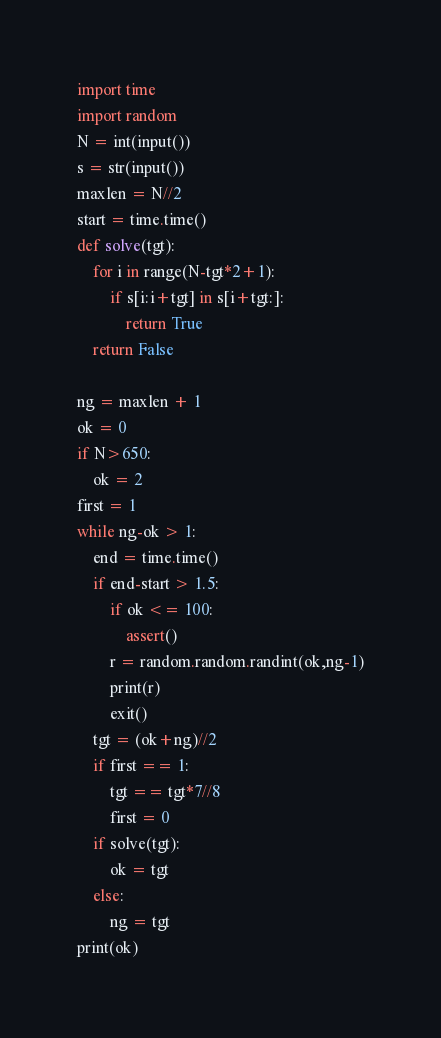Convert code to text. <code><loc_0><loc_0><loc_500><loc_500><_Python_>import time
import random
N = int(input())
s = str(input())
maxlen = N//2
start = time.time()
def solve(tgt):
    for i in range(N-tgt*2+1):
        if s[i:i+tgt] in s[i+tgt:]:
            return True
    return False

ng = maxlen + 1
ok = 0
if N>650:
    ok = 2
first = 1
while ng-ok > 1:
    end = time.time()
    if end-start > 1.5:
        if ok <= 100:
            assert()
        r = random.random.randint(ok,ng-1)
        print(r)
        exit()
    tgt = (ok+ng)//2
    if first == 1:
        tgt == tgt*7//8
        first = 0
    if solve(tgt):
        ok = tgt
    else:
        ng = tgt
print(ok)
</code> 